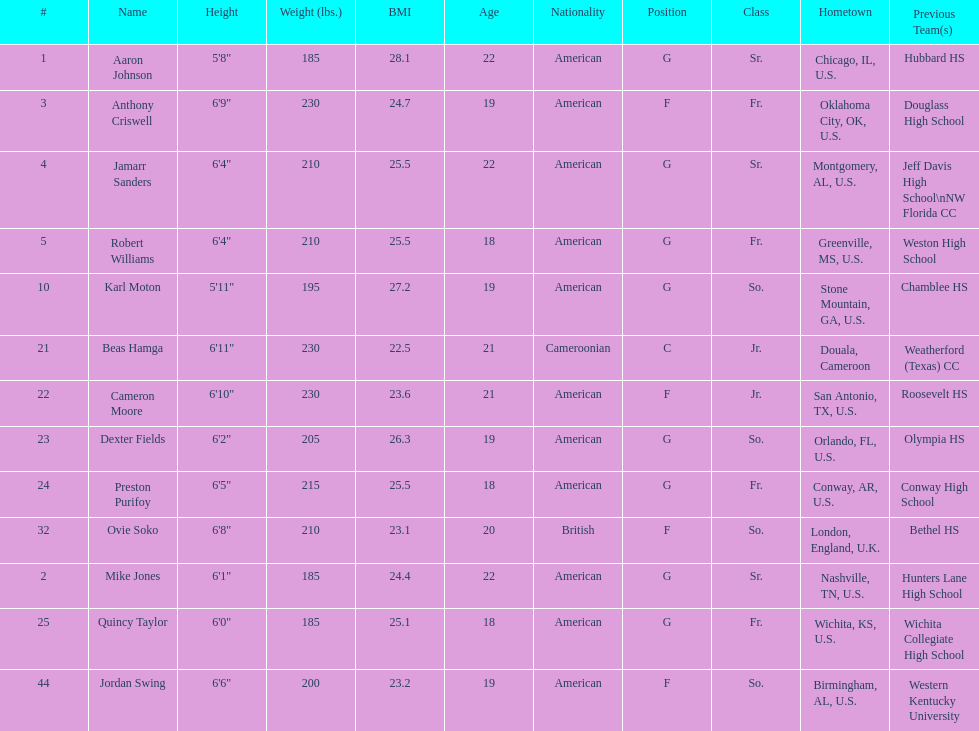How many players were on the 2010-11 uab blazers men's basketball team? 13. 